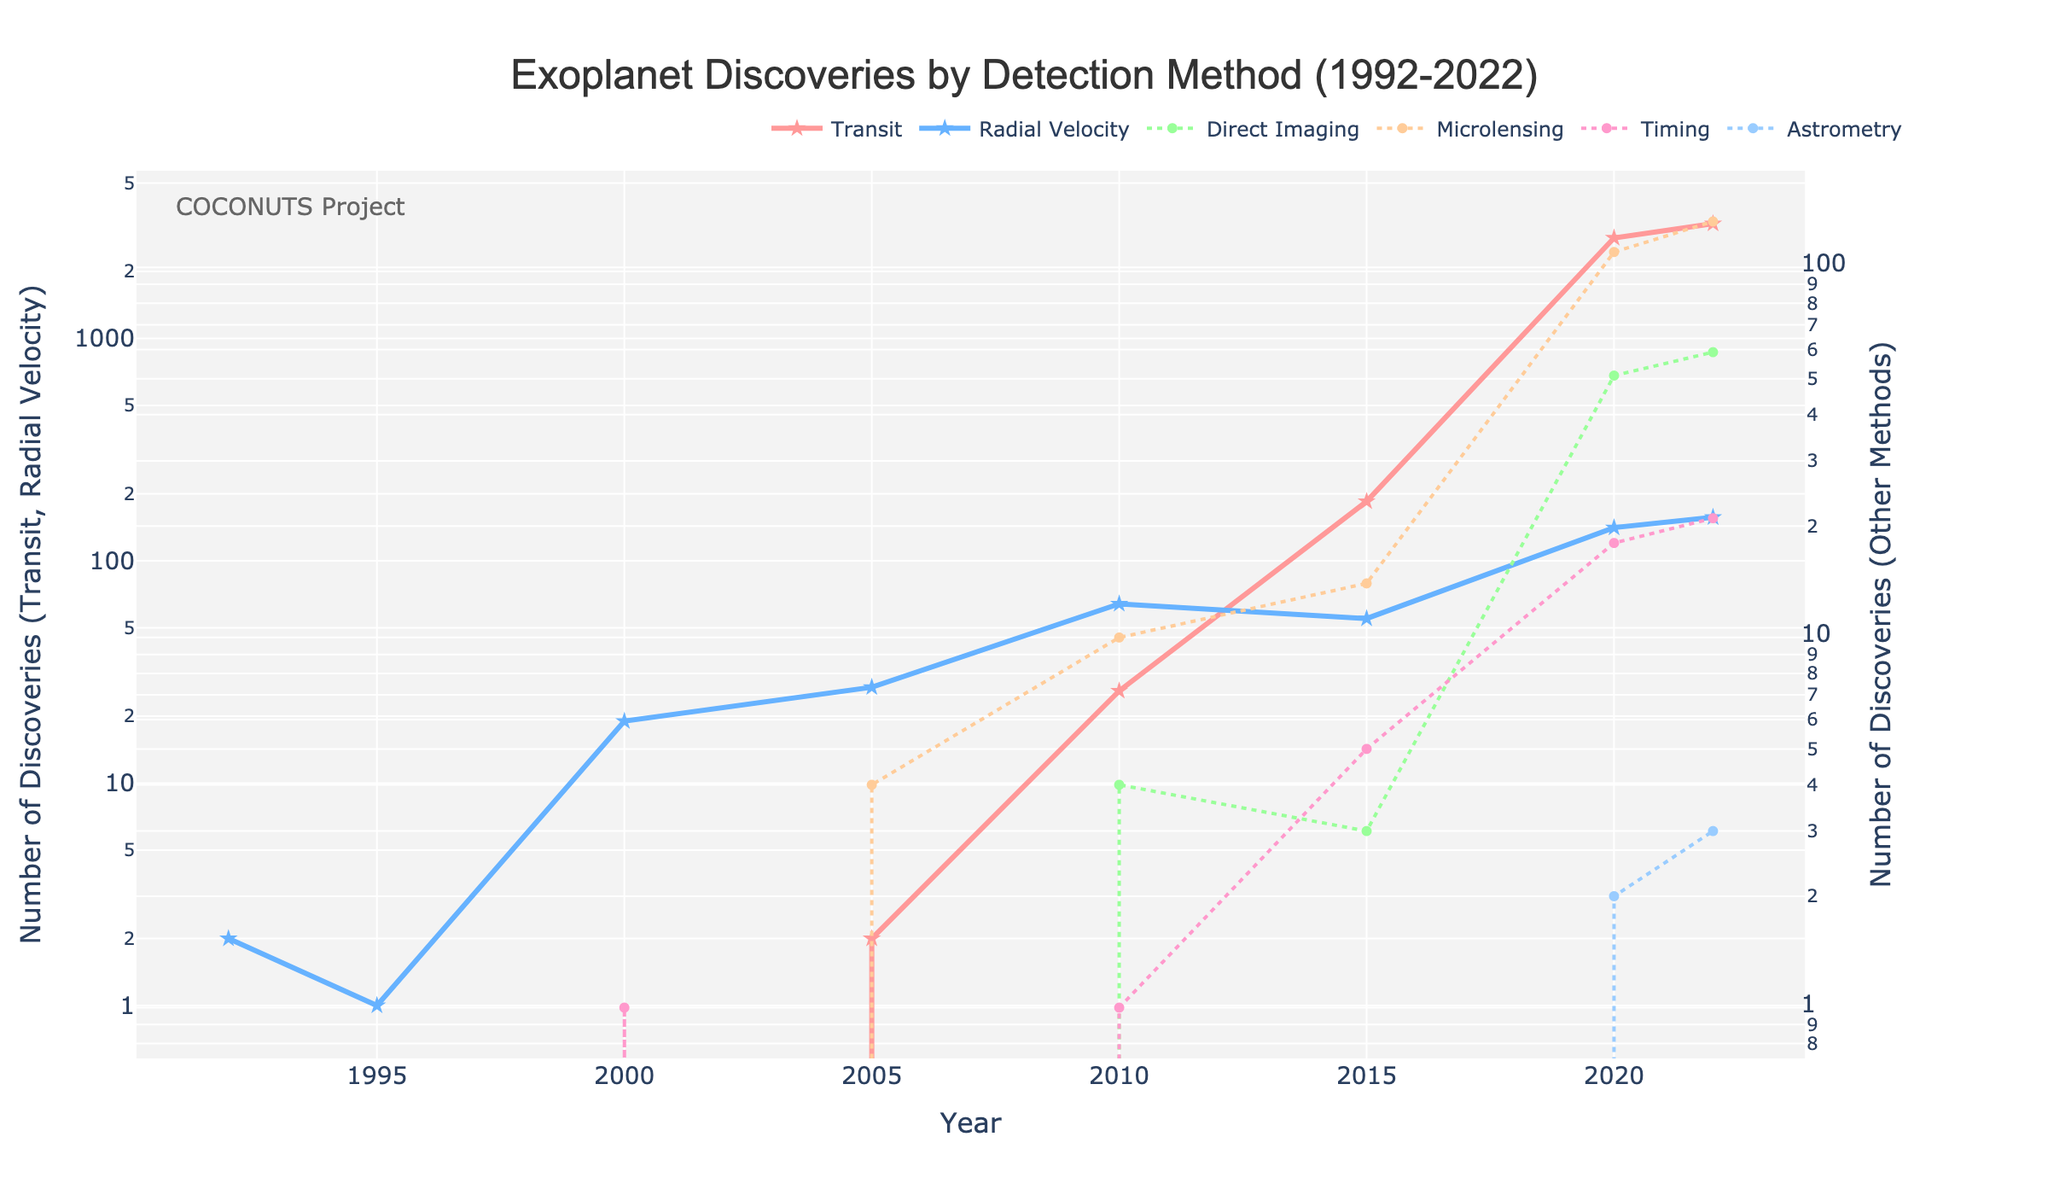What's the total number of exoplanets discovered by the Transit method by 2022? We need to look at the data points for the Transit method and sum them up. From the figure, the numbers are: 0 (1992), 0 (1995), 0 (2000), 2 (2005), 26 (2010), 185 (2015), 2832 (2020), 3284 (2022). The total is 0 + 0 + 0 + 2 + 26 + 185 + 2832 + 3284 = 6329.
Answer: 6329 In which year did the Radial Velocity method have its largest number of discoveries? We look at the data points for the Radial Velocity method and identify the year with the highest value. The numbers are: 2 (1992), 1 (1995), 19 (2000), 27 (2005), 64 (2010), 55 (2015), 141 (2020), 157 (2022). The highest value is in the year 2010 with 64 discoveries.
Answer: 2010 Compare the number of discoveries between Transit and Direct Imaging methods in 2020. Which was higher and by how much? We need to find the values for the year 2020 for both Transit and Direct Imaging methods. The values are 2832 (Transit) and 51 (Direct Imaging). We subtract the smaller value from the larger value: 2832 - 51 = 2781. Transit had 2781 more discoveries than Direct Imaging.
Answer: Transit by 2781 Which detection method shows a steady increase over the years, without any years of decline? We observe the trends for each method to see if any of them have only increased or remained the same without declining between the given years. The Transit method shows continuous growth without a decline across the years.
Answer: Transit By what factor did the number of exoplanets discovered via Microlensing increase from 2005 to 2022? We need to find the values for Microlensing in the years 2005 and 2022, which are 4 and 133 respectively. We divide the value in 2022 by the value in 2005: 133 / 4 = 33.25. The Microlensing discoveries increased by a factor of 33.25 from 2005 to 2022.
Answer: 33.25 What is the difference in the number of discoveries using the Astrometry method between 2020 and 2022? We look at the data points for Astrometry in 2020 and 2022, which are 2 and 3 respectively. The difference is 3 - 2 = 1. There was 1 more discovery in 2022 compared to 2020.
Answer: 1 Compare the total discoveries by Radial Velocity and Transit methods in 2015. What is their ratio? We sum the values for both methods in 2015. The values are 185 (Transit) and 55 (Radial Velocity). The ratio is 185 / 55 = 3.36. The ratio of Transit to Radial Velocity discoveries is approximately 3.36.
Answer: 3.36 Which methods show non-zero discoveries in 2005? We look at all methods and their values for the year 2005. The non-zero values are in Transit (2), Radial Velocity (27), and Microlensing (4).
Answer: Transit, Radial Velocity, Microlensing Between 2010 and 2015, which method had the highest absolute increase in discovery numbers? We compare the differences for each method between the years 2010 and 2015. The values are: Transit: 185 - 26 = 159; Radial Velocity: 55 - 64 = -9; Direct Imaging: 3 - 4 = -1; Microlensing: 14 - 10 = 4; Timing: 5 - 1 = 4; Astrometry: 0 - 0 = 0. The highest increase is for the Transit method with 159 additional discoveries.
Answer: Transit Which detection method had consistently fewer than 5 discoveries per year until 2020? Observing the data for each method, Direct Imaging shows fewer than 5 discoveries per year from 1992 until 2010 and grows slightly higher in later years. However, Astrometry has fewer than 5 discoveries per year consistently across all years until 2020.
Answer: Astrometry 